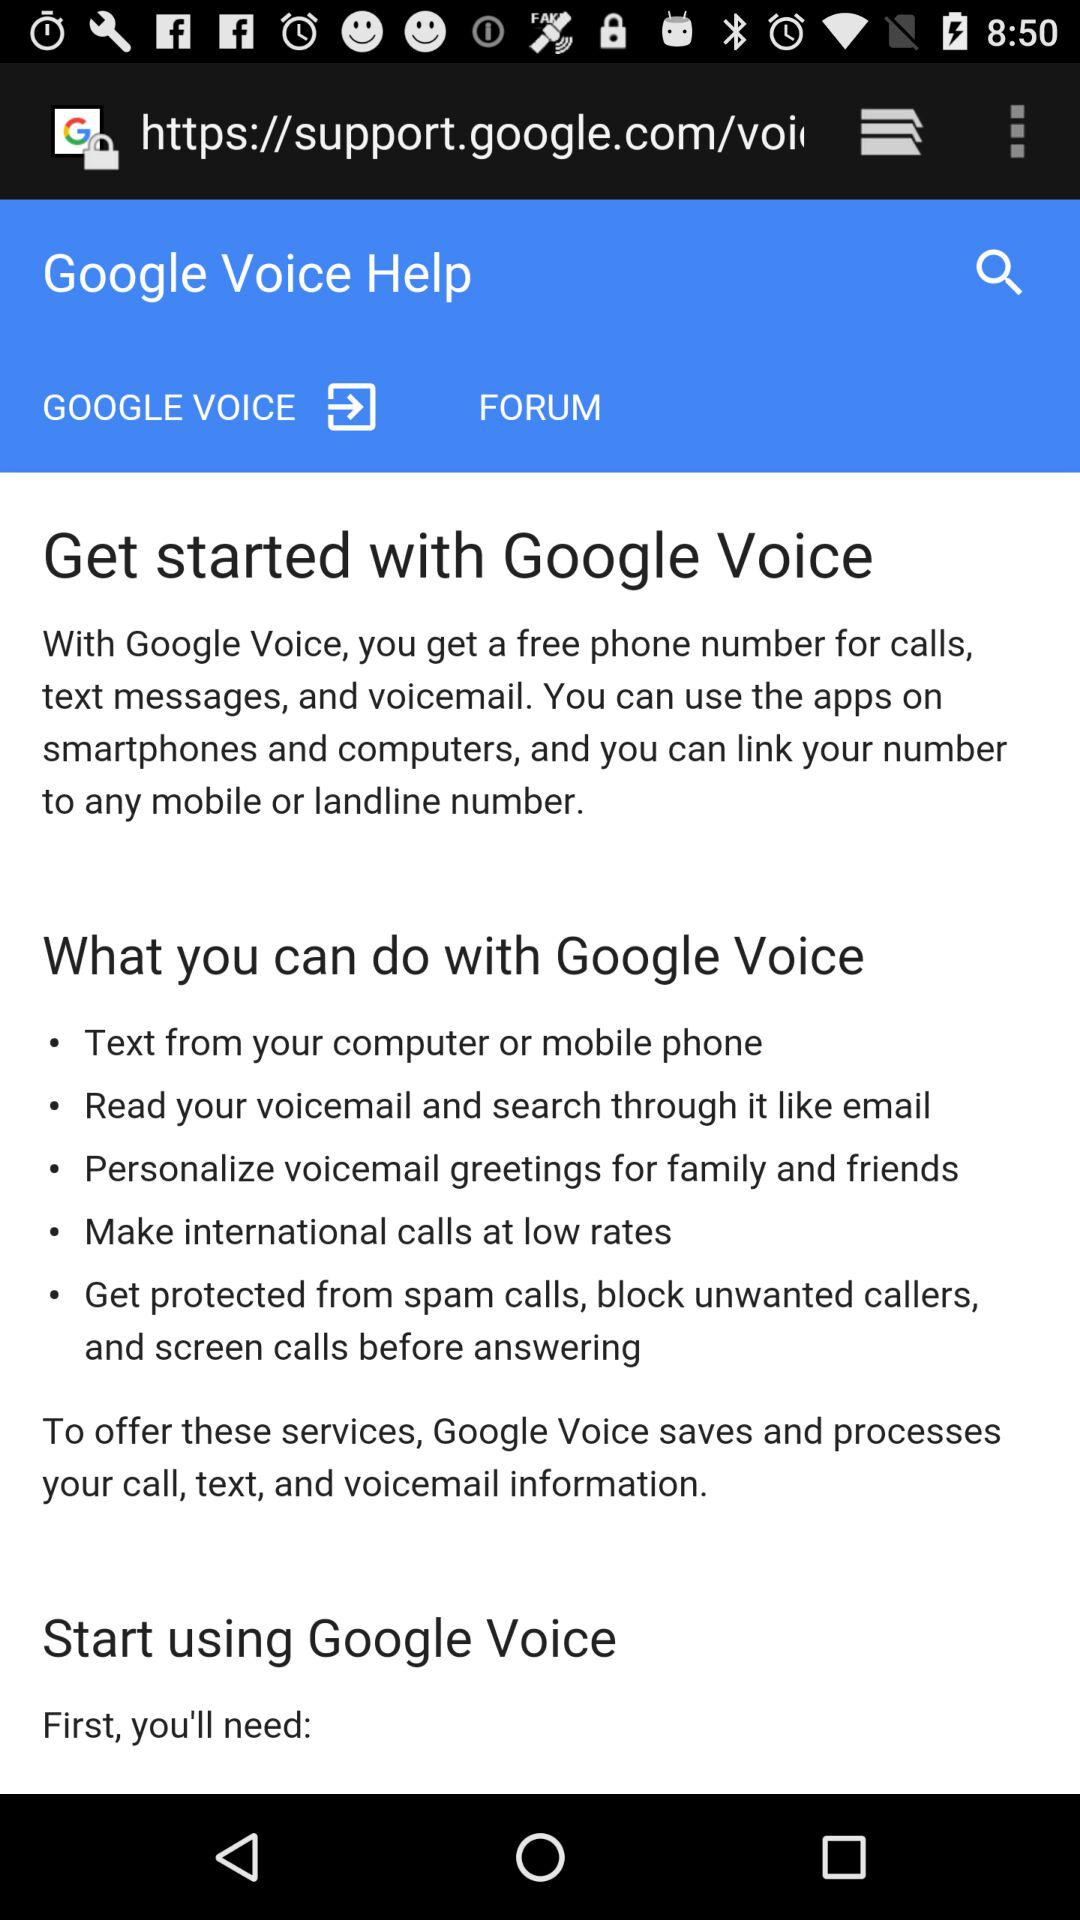We can make international calls at what rate?
When the provided information is insufficient, respond with <no answer>. <no answer> 